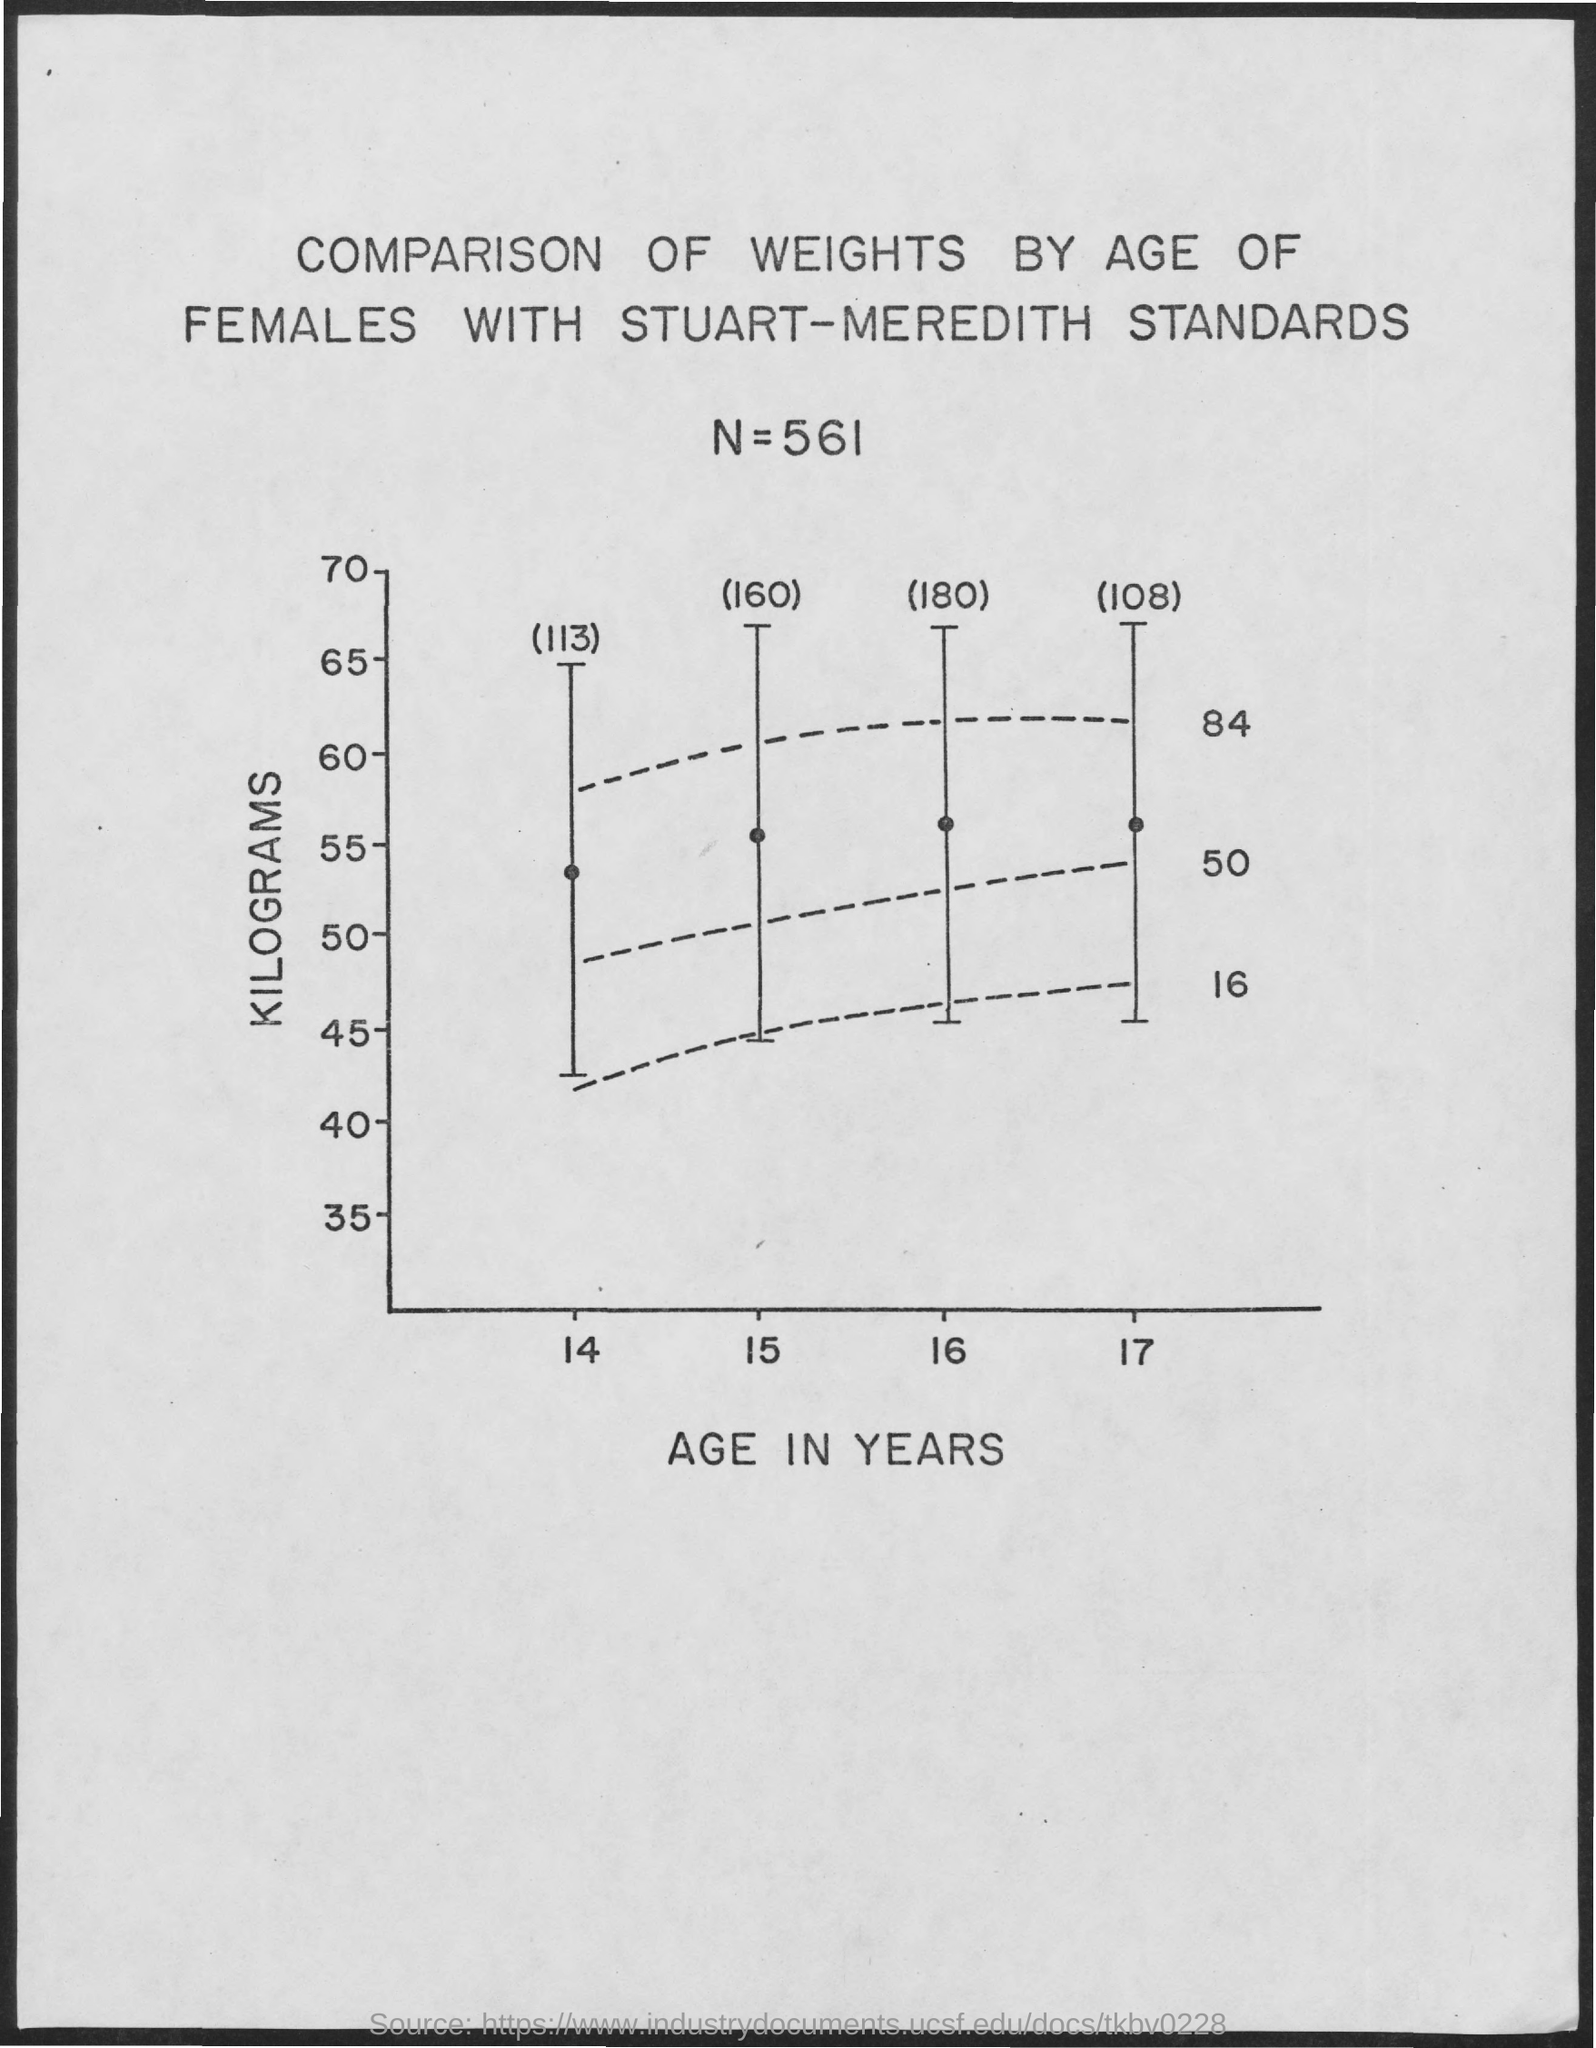What is plotted in the y-axis?
Offer a very short reply. Kilograms. What is plotted in the x-axis?
Give a very brief answer. Age in Years. Which standard is used to plot the graph?
Provide a short and direct response. Stuart-meredith. 